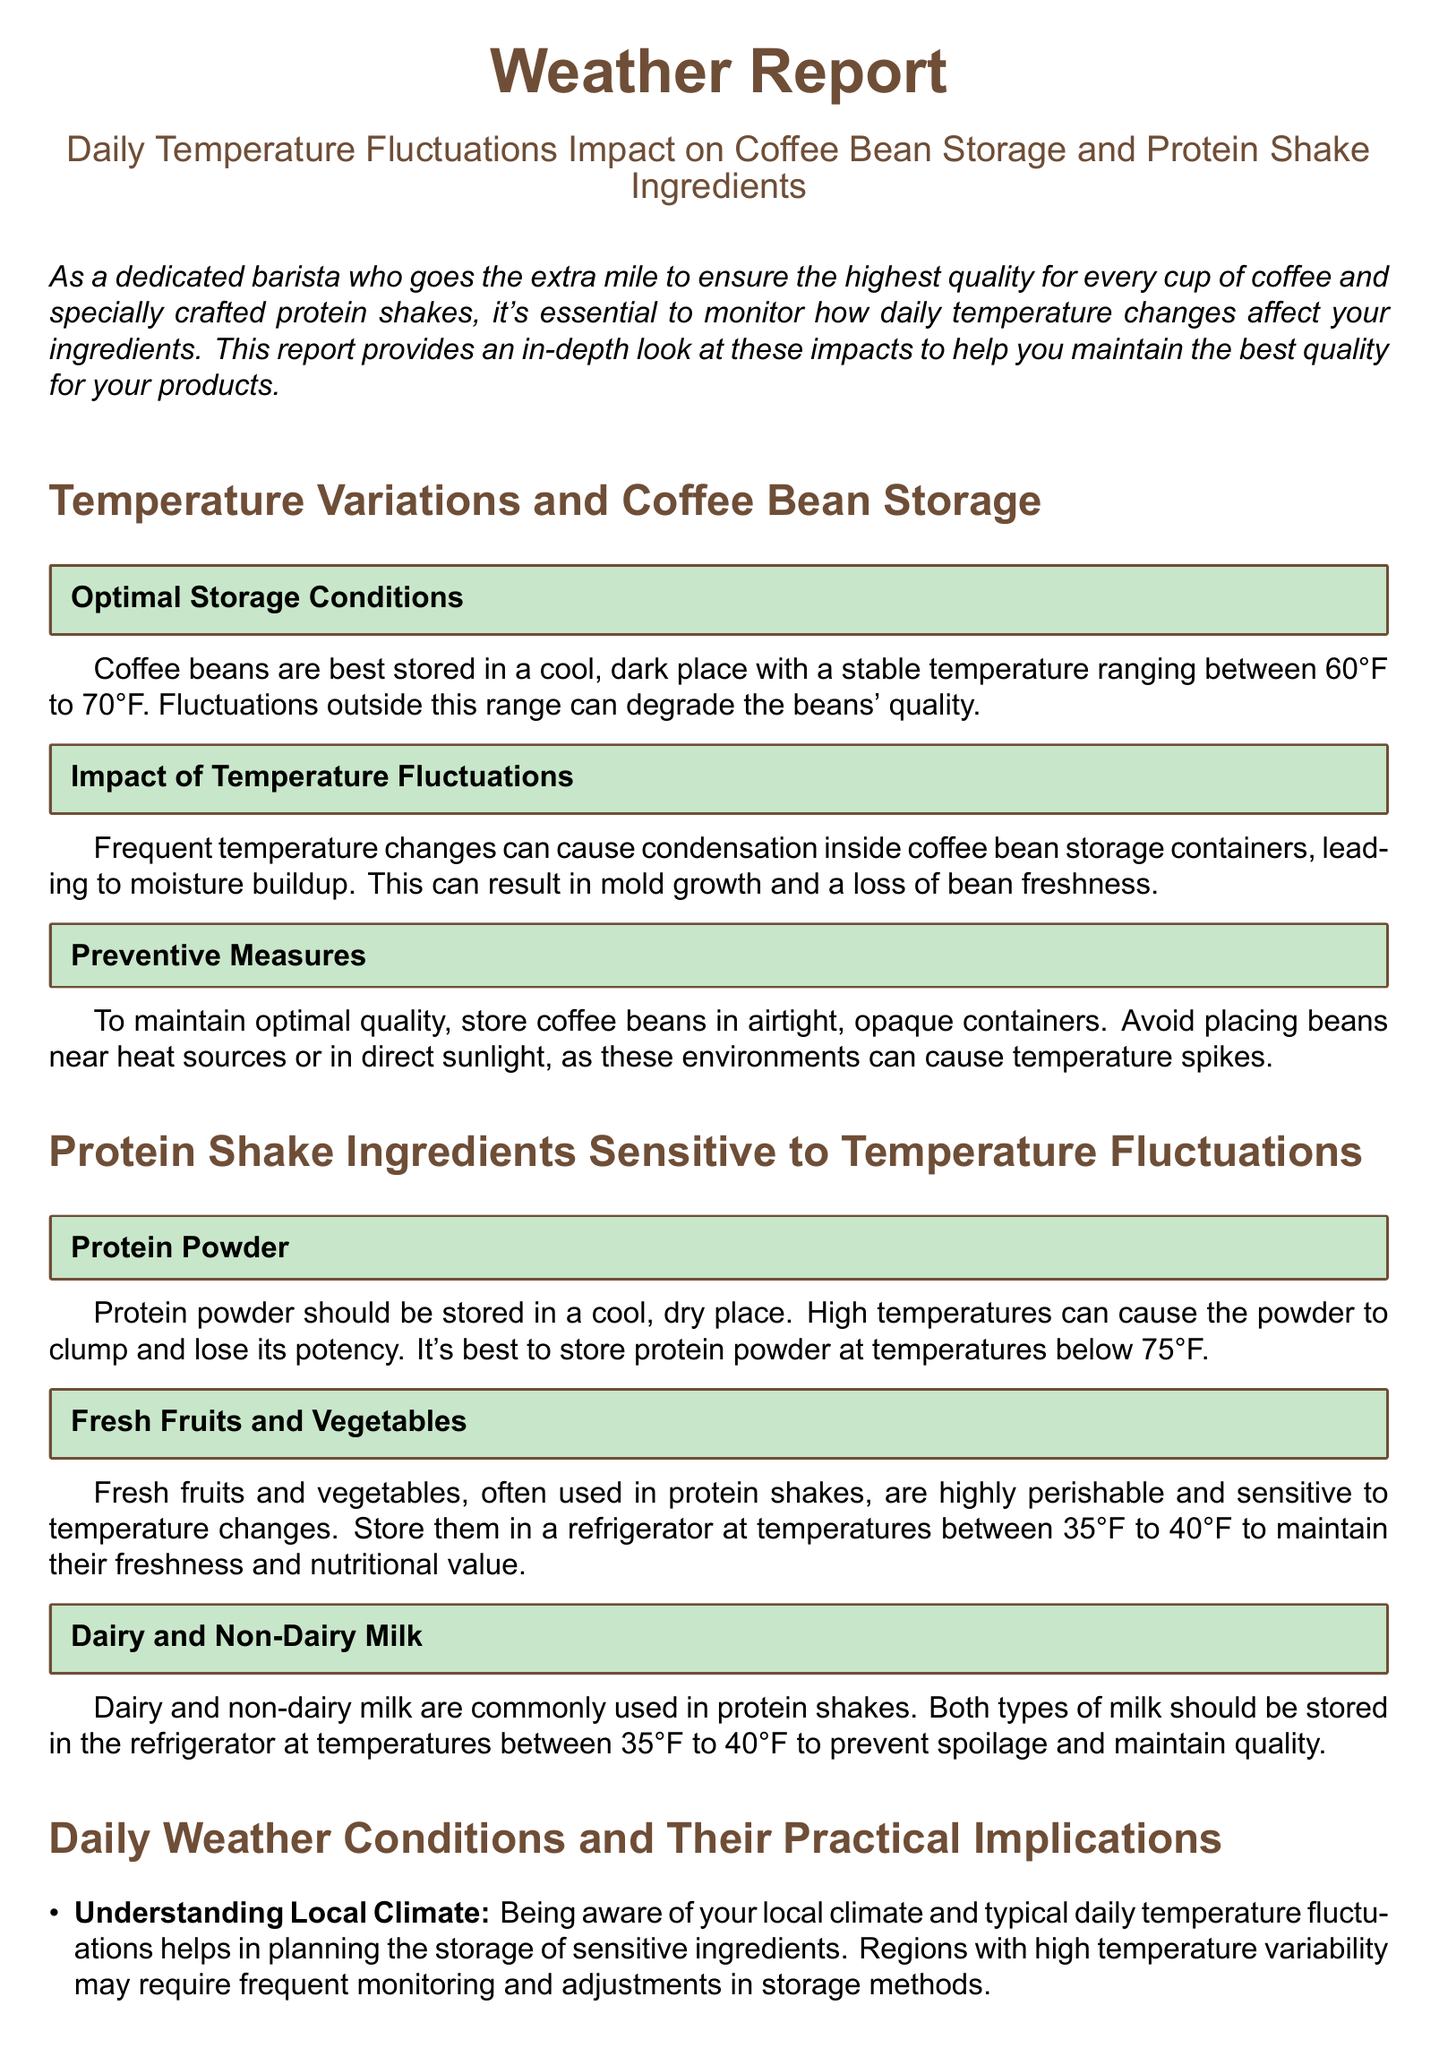What is the optimal temperature range for coffee bean storage? The optimal temperature range for coffee bean storage is mentioned as between 60°F to 70°F.
Answer: 60°F to 70°F What happens to coffee beans with frequent temperature changes? Frequent temperature changes can cause condensation, leading to moisture buildup and potential mold growth.
Answer: Mold growth What temperature should protein powder be stored below? It is advised to store protein powder at temperatures below 75°F.
Answer: Below 75°F What is the recommended storage temperature for fresh fruits and vegetables? Fresh fruits and vegetables should be stored at temperatures between 35°F to 40°F.
Answer: 35°F to 40°F What should you do to prepare for unexpected weather changes? Having an emergency plan, such as backup storage solutions or temperature-controlled options, can minimize potential damage.
Answer: Emergency plan What are some preventive measures for coffee bean storage? Preventive measures include storing coffee beans in airtight, opaque containers and avoiding direct sunlight.
Answer: Airtight, opaque containers What is a common season-related challenge mentioned in the report? The report highlights that summer heat may necessitate additional precautions for ingredient storage.
Answer: Summer heat How can being aware of local climate help in ingredient storage? Being aware helps in planning the storage of sensitive ingredients, especially in regions with high temperature variability.
Answer: Planning storage What type of milk requires refrigeration to prevent spoilage? Both dairy and non-dairy milk should be refrigerated.
Answer: Dairy and non-dairy milk 